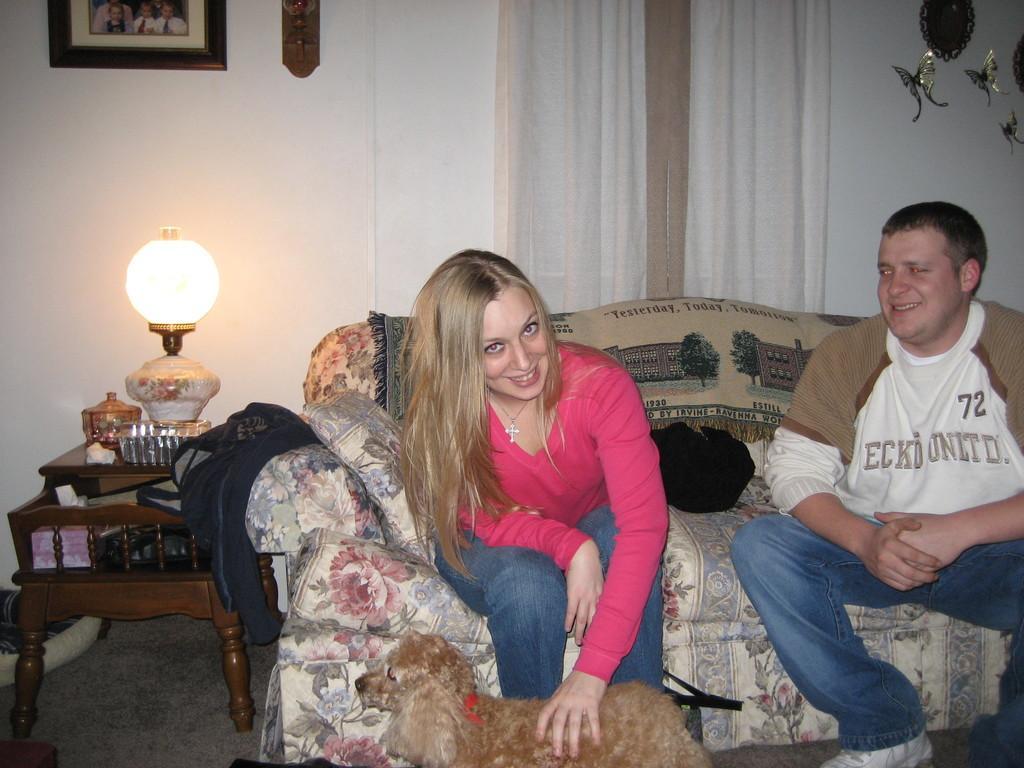Describe this image in one or two sentences. In this picture we can see a woman and a man sitting on the sofa. This is dog and there is a chair. On the background we can see the wall. And there is a frame. This is curtain. And we can see a lamp on the table. And this is floor. 